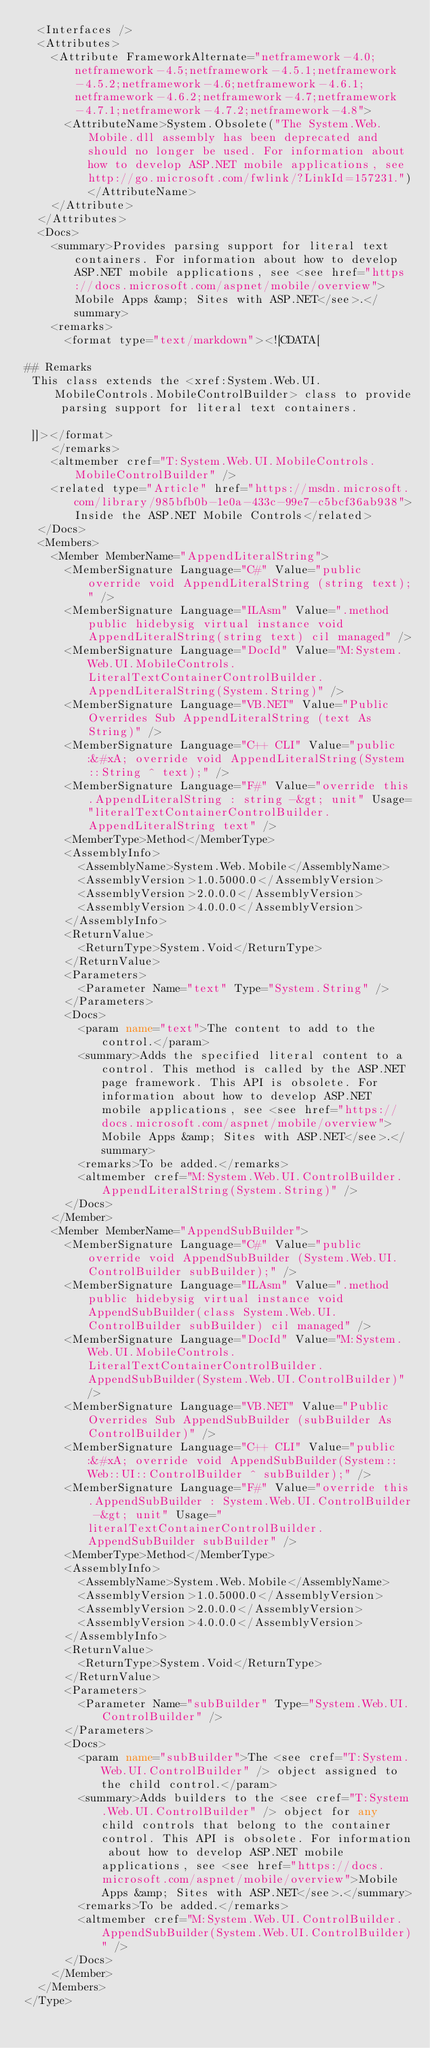Convert code to text. <code><loc_0><loc_0><loc_500><loc_500><_XML_>  <Interfaces />
  <Attributes>
    <Attribute FrameworkAlternate="netframework-4.0;netframework-4.5;netframework-4.5.1;netframework-4.5.2;netframework-4.6;netframework-4.6.1;netframework-4.6.2;netframework-4.7;netframework-4.7.1;netframework-4.7.2;netframework-4.8">
      <AttributeName>System.Obsolete("The System.Web.Mobile.dll assembly has been deprecated and should no longer be used. For information about how to develop ASP.NET mobile applications, see http://go.microsoft.com/fwlink/?LinkId=157231.")</AttributeName>
    </Attribute>
  </Attributes>
  <Docs>
    <summary>Provides parsing support for literal text containers. For information about how to develop ASP.NET mobile applications, see <see href="https://docs.microsoft.com/aspnet/mobile/overview">Mobile Apps &amp; Sites with ASP.NET</see>.</summary>
    <remarks>
      <format type="text/markdown"><![CDATA[  
  
## Remarks  
 This class extends the <xref:System.Web.UI.MobileControls.MobileControlBuilder> class to provide parsing support for literal text containers.  
  
 ]]></format>
    </remarks>
    <altmember cref="T:System.Web.UI.MobileControls.MobileControlBuilder" />
    <related type="Article" href="https://msdn.microsoft.com/library/985bfb0b-1e0a-433c-99e7-c5bcf36ab938">Inside the ASP.NET Mobile Controls</related>
  </Docs>
  <Members>
    <Member MemberName="AppendLiteralString">
      <MemberSignature Language="C#" Value="public override void AppendLiteralString (string text);" />
      <MemberSignature Language="ILAsm" Value=".method public hidebysig virtual instance void AppendLiteralString(string text) cil managed" />
      <MemberSignature Language="DocId" Value="M:System.Web.UI.MobileControls.LiteralTextContainerControlBuilder.AppendLiteralString(System.String)" />
      <MemberSignature Language="VB.NET" Value="Public Overrides Sub AppendLiteralString (text As String)" />
      <MemberSignature Language="C++ CLI" Value="public:&#xA; override void AppendLiteralString(System::String ^ text);" />
      <MemberSignature Language="F#" Value="override this.AppendLiteralString : string -&gt; unit" Usage="literalTextContainerControlBuilder.AppendLiteralString text" />
      <MemberType>Method</MemberType>
      <AssemblyInfo>
        <AssemblyName>System.Web.Mobile</AssemblyName>
        <AssemblyVersion>1.0.5000.0</AssemblyVersion>
        <AssemblyVersion>2.0.0.0</AssemblyVersion>
        <AssemblyVersion>4.0.0.0</AssemblyVersion>
      </AssemblyInfo>
      <ReturnValue>
        <ReturnType>System.Void</ReturnType>
      </ReturnValue>
      <Parameters>
        <Parameter Name="text" Type="System.String" />
      </Parameters>
      <Docs>
        <param name="text">The content to add to the control.</param>
        <summary>Adds the specified literal content to a control. This method is called by the ASP.NET page framework. This API is obsolete. For information about how to develop ASP.NET mobile applications, see <see href="https://docs.microsoft.com/aspnet/mobile/overview">Mobile Apps &amp; Sites with ASP.NET</see>.</summary>
        <remarks>To be added.</remarks>
        <altmember cref="M:System.Web.UI.ControlBuilder.AppendLiteralString(System.String)" />
      </Docs>
    </Member>
    <Member MemberName="AppendSubBuilder">
      <MemberSignature Language="C#" Value="public override void AppendSubBuilder (System.Web.UI.ControlBuilder subBuilder);" />
      <MemberSignature Language="ILAsm" Value=".method public hidebysig virtual instance void AppendSubBuilder(class System.Web.UI.ControlBuilder subBuilder) cil managed" />
      <MemberSignature Language="DocId" Value="M:System.Web.UI.MobileControls.LiteralTextContainerControlBuilder.AppendSubBuilder(System.Web.UI.ControlBuilder)" />
      <MemberSignature Language="VB.NET" Value="Public Overrides Sub AppendSubBuilder (subBuilder As ControlBuilder)" />
      <MemberSignature Language="C++ CLI" Value="public:&#xA; override void AppendSubBuilder(System::Web::UI::ControlBuilder ^ subBuilder);" />
      <MemberSignature Language="F#" Value="override this.AppendSubBuilder : System.Web.UI.ControlBuilder -&gt; unit" Usage="literalTextContainerControlBuilder.AppendSubBuilder subBuilder" />
      <MemberType>Method</MemberType>
      <AssemblyInfo>
        <AssemblyName>System.Web.Mobile</AssemblyName>
        <AssemblyVersion>1.0.5000.0</AssemblyVersion>
        <AssemblyVersion>2.0.0.0</AssemblyVersion>
        <AssemblyVersion>4.0.0.0</AssemblyVersion>
      </AssemblyInfo>
      <ReturnValue>
        <ReturnType>System.Void</ReturnType>
      </ReturnValue>
      <Parameters>
        <Parameter Name="subBuilder" Type="System.Web.UI.ControlBuilder" />
      </Parameters>
      <Docs>
        <param name="subBuilder">The <see cref="T:System.Web.UI.ControlBuilder" /> object assigned to the child control.</param>
        <summary>Adds builders to the <see cref="T:System.Web.UI.ControlBuilder" /> object for any child controls that belong to the container control. This API is obsolete. For information about how to develop ASP.NET mobile applications, see <see href="https://docs.microsoft.com/aspnet/mobile/overview">Mobile Apps &amp; Sites with ASP.NET</see>.</summary>
        <remarks>To be added.</remarks>
        <altmember cref="M:System.Web.UI.ControlBuilder.AppendSubBuilder(System.Web.UI.ControlBuilder)" />
      </Docs>
    </Member>
  </Members>
</Type>
</code> 